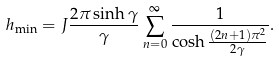Convert formula to latex. <formula><loc_0><loc_0><loc_500><loc_500>h _ { \min } = J \frac { 2 \pi \sinh \gamma } { \gamma } \sum _ { n = 0 } ^ { \infty } \frac { 1 } { \cosh \frac { \left ( 2 n + 1 \right ) \pi ^ { 2 } } { 2 \gamma } } .</formula> 